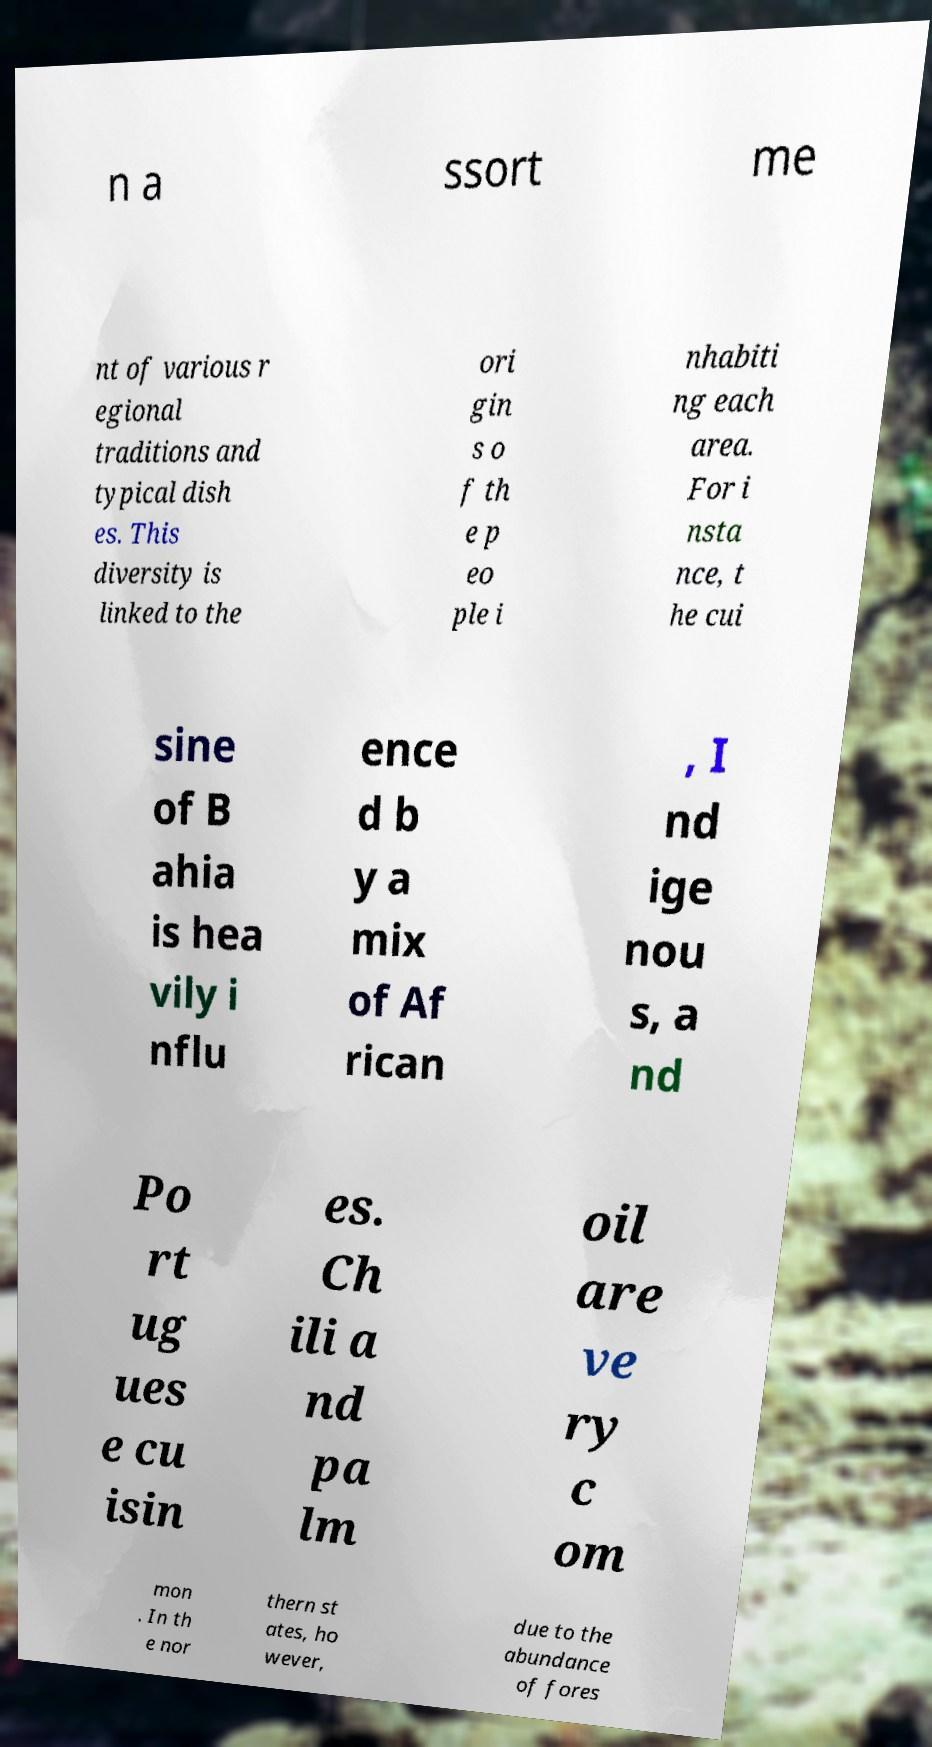Can you read and provide the text displayed in the image?This photo seems to have some interesting text. Can you extract and type it out for me? n a ssort me nt of various r egional traditions and typical dish es. This diversity is linked to the ori gin s o f th e p eo ple i nhabiti ng each area. For i nsta nce, t he cui sine of B ahia is hea vily i nflu ence d b y a mix of Af rican , I nd ige nou s, a nd Po rt ug ues e cu isin es. Ch ili a nd pa lm oil are ve ry c om mon . In th e nor thern st ates, ho wever, due to the abundance of fores 